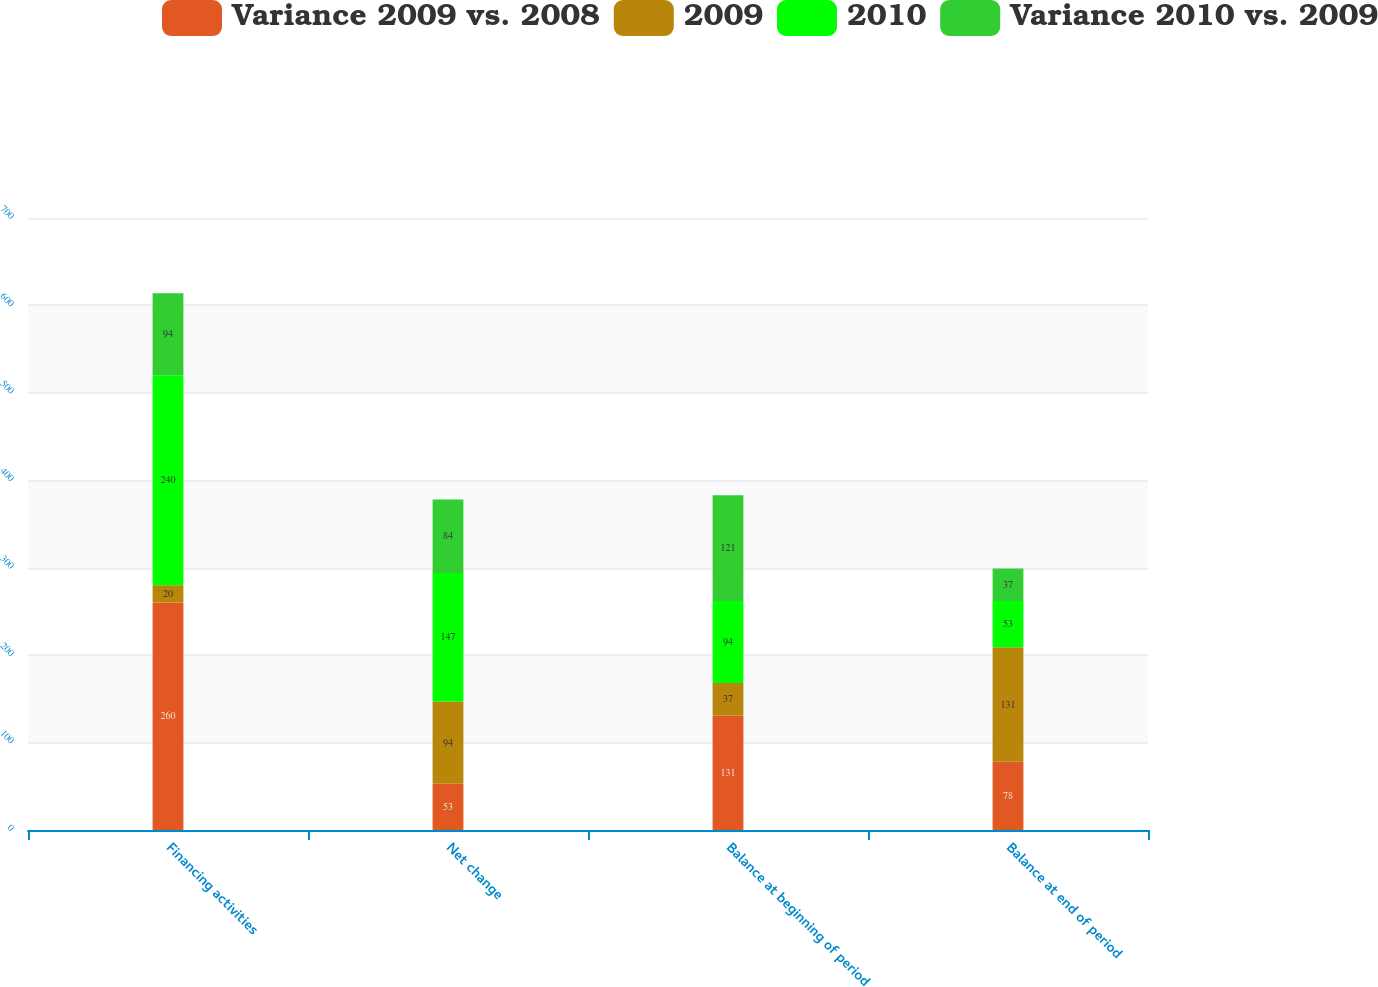Convert chart to OTSL. <chart><loc_0><loc_0><loc_500><loc_500><stacked_bar_chart><ecel><fcel>Financing activities<fcel>Net change<fcel>Balance at beginning of period<fcel>Balance at end of period<nl><fcel>Variance 2009 vs. 2008<fcel>260<fcel>53<fcel>131<fcel>78<nl><fcel>2009<fcel>20<fcel>94<fcel>37<fcel>131<nl><fcel>2010<fcel>240<fcel>147<fcel>94<fcel>53<nl><fcel>Variance 2010 vs. 2009<fcel>94<fcel>84<fcel>121<fcel>37<nl></chart> 